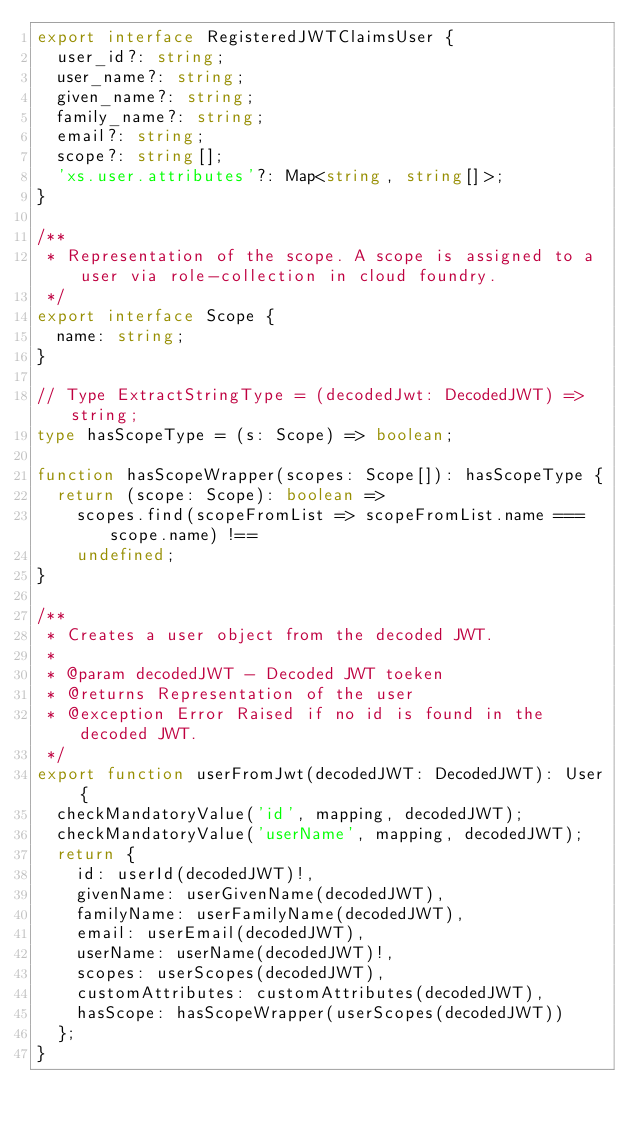Convert code to text. <code><loc_0><loc_0><loc_500><loc_500><_TypeScript_>export interface RegisteredJWTClaimsUser {
  user_id?: string;
  user_name?: string;
  given_name?: string;
  family_name?: string;
  email?: string;
  scope?: string[];
  'xs.user.attributes'?: Map<string, string[]>;
}

/**
 * Representation of the scope. A scope is assigned to a user via role-collection in cloud foundry.
 */
export interface Scope {
  name: string;
}

// Type ExtractStringType = (decodedJwt: DecodedJWT) => string;
type hasScopeType = (s: Scope) => boolean;

function hasScopeWrapper(scopes: Scope[]): hasScopeType {
  return (scope: Scope): boolean =>
    scopes.find(scopeFromList => scopeFromList.name === scope.name) !==
    undefined;
}

/**
 * Creates a user object from the decoded JWT.
 *
 * @param decodedJWT - Decoded JWT toeken
 * @returns Representation of the user
 * @exception Error Raised if no id is found in the decoded JWT.
 */
export function userFromJwt(decodedJWT: DecodedJWT): User {
  checkMandatoryValue('id', mapping, decodedJWT);
  checkMandatoryValue('userName', mapping, decodedJWT);
  return {
    id: userId(decodedJWT)!,
    givenName: userGivenName(decodedJWT),
    familyName: userFamilyName(decodedJWT),
    email: userEmail(decodedJWT),
    userName: userName(decodedJWT)!,
    scopes: userScopes(decodedJWT),
    customAttributes: customAttributes(decodedJWT),
    hasScope: hasScopeWrapper(userScopes(decodedJWT))
  };
}
</code> 